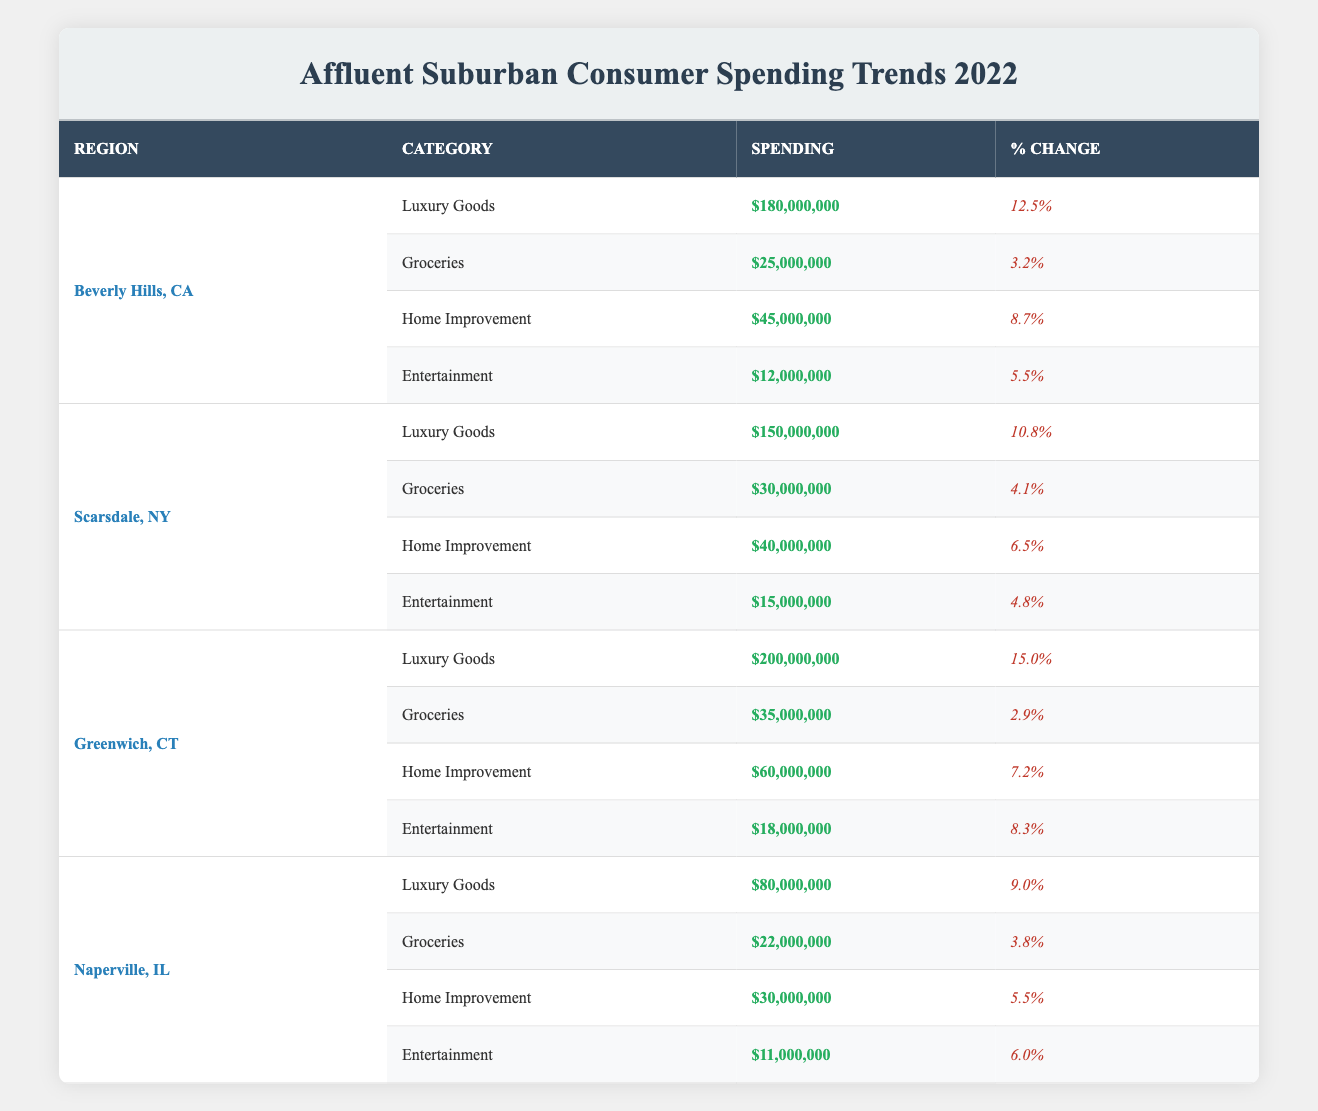What was the total consumer spending on luxury goods in Beverly Hills, CA in 2022? The spending on luxury goods in Beverly Hills, CA is $180,000,000. This value is directly taken from the table without needing any calculation.
Answer: 180000000 Which region had the highest percentage change in spending for home improvement? In the table, the percentage change for home improvement is highest in Beverly Hills, CA at 8.7%, compared to other regions (Scarsdale - 6.5%, Greenwich - 7.2%, Naperville - 5.5%).
Answer: Beverly Hills, CA What is the average spending on groceries across all four regions? The total spending on groceries is $25,000,000 (Beverly Hills, CA) + $30,000,000 (Scarsdale, NY) + $35,000,000 (Greenwich, CT) + $22,000,000 (Naperville, IL) = $112,000,000. There are 4 regions, so the average is $112,000,000 / 4 = $28,000,000.
Answer: 28000000 Did Scarsdale, NY spend more on entertainment than Naperville, IL? Scarsdale, NY spent $15,000,000 on entertainment, while Naperville, IL spent $11,000,000. Since $15,000,000 is greater than $11,000,000, the statement is true.
Answer: Yes What is the combined spending on luxury goods and home improvement in Greenwich, CT? In Greenwich, CT, luxury goods spending is $200,000,000 and home improvement spending is $60,000,000. Adding these gives $200,000,000 + $60,000,000 = $260,000,000 for combined spending.
Answer: 260000000 Which category saw the least spending in Naperville, IL? In Naperville, IL, the entertainment category saw the least spending at $11,000,000, compared to other categories (luxury goods - $80,000,000, groceries - $22,000,000, and home improvement - $30,000,000) in the same region.
Answer: Entertainment What region had the lowest percentage change in consumer spending on groceries? Reviewing the table, Greenwich, CT had the lowest percentage change in groceries at 2.9%, as the other regions had higher percentage changes (Beverly Hills - 3.2%, Scarsdale - 4.1%, Naperville - 3.8%).
Answer: Greenwich, CT If we subtract the entertainment spending from the luxury goods spending in Beverly Hills, CA, what is the result? The luxury goods spending in Beverly Hills, CA is $180,000,000 and entertainment spending is $12,000,000. When we subtract, we get $180,000,000 - $12,000,000 = $168,000,000.
Answer: 168000000 Which region had the highest overall consumer spending among all categories? By summing all category spendings in each region: Beverly Hills = $180,000,000 + $25,000,000 + $45,000,000 + $12,000,000 = $262,000,000; Scarsdale = $150,000,000 + $30,000,000 + $40,000,000 + $15,000,000 = $235,000,000; Greenwich = $200,000,000 + $35,000,000 + $60,000,000 + $18,000,000 = $313,000,000; Naperville = $80,000,000 + $22,000,000 + $30,000,000 + $11,000,000 = $143,000,000. Hence, Greenwich had the highest spending.
Answer: Greenwich, CT 